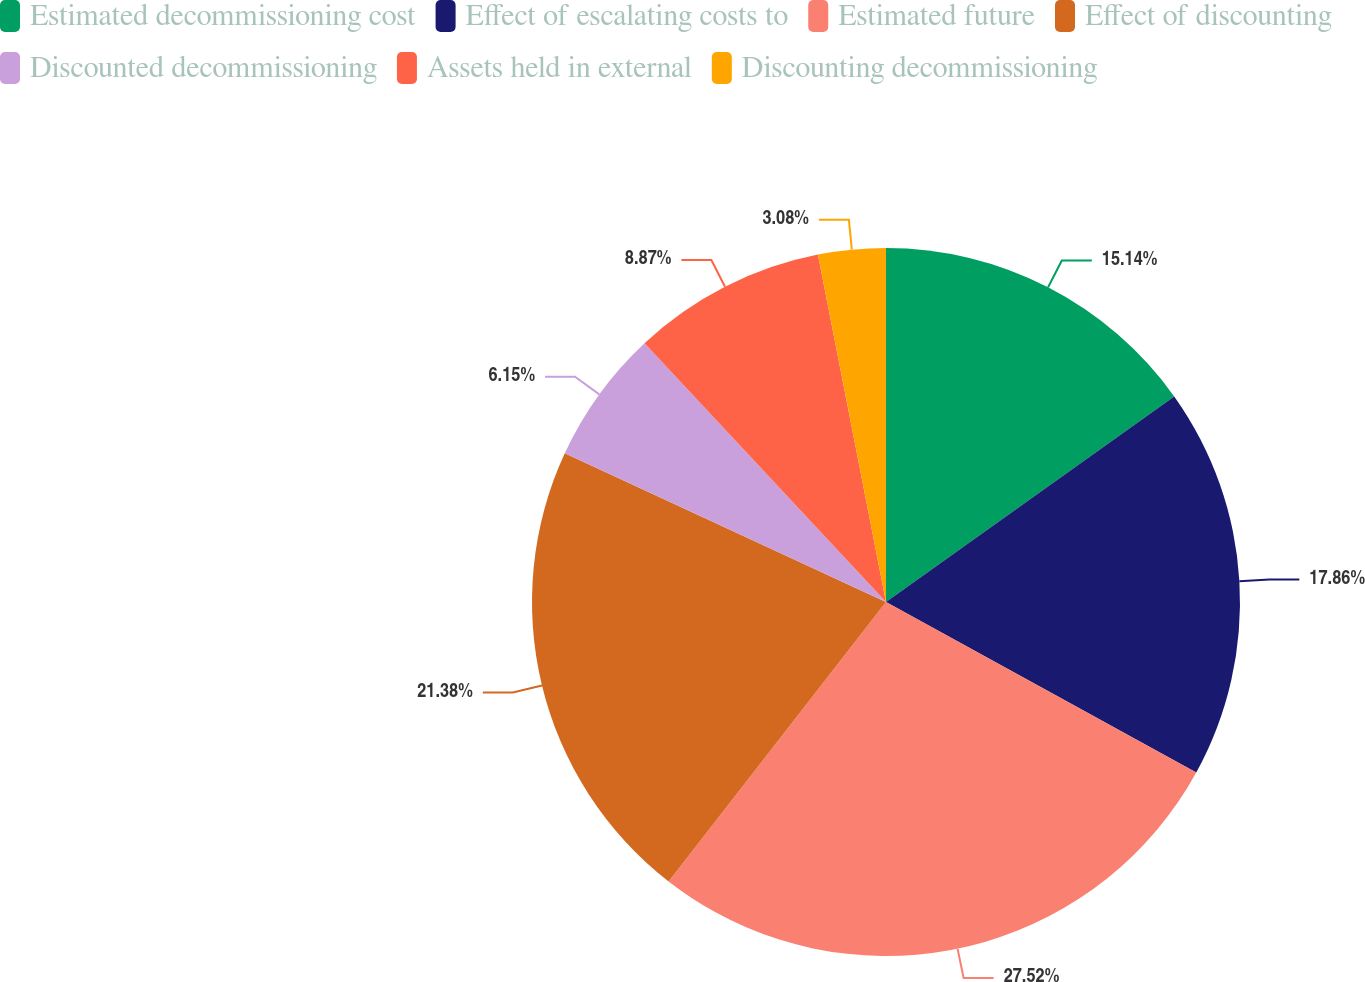Convert chart. <chart><loc_0><loc_0><loc_500><loc_500><pie_chart><fcel>Estimated decommissioning cost<fcel>Effect of escalating costs to<fcel>Estimated future<fcel>Effect of discounting<fcel>Discounted decommissioning<fcel>Assets held in external<fcel>Discounting decommissioning<nl><fcel>15.14%<fcel>17.86%<fcel>27.53%<fcel>21.38%<fcel>6.15%<fcel>8.87%<fcel>3.08%<nl></chart> 